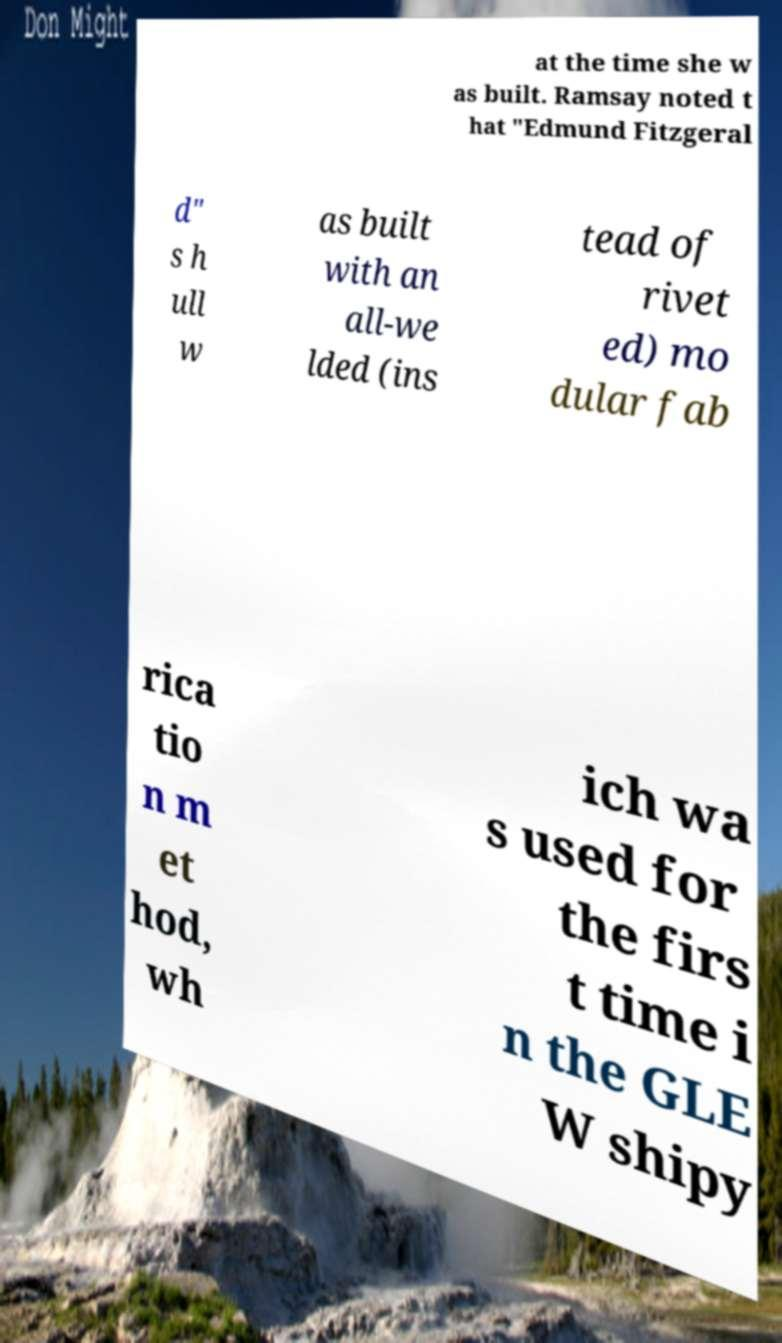Could you assist in decoding the text presented in this image and type it out clearly? at the time she w as built. Ramsay noted t hat "Edmund Fitzgeral d" s h ull w as built with an all-we lded (ins tead of rivet ed) mo dular fab rica tio n m et hod, wh ich wa s used for the firs t time i n the GLE W shipy 